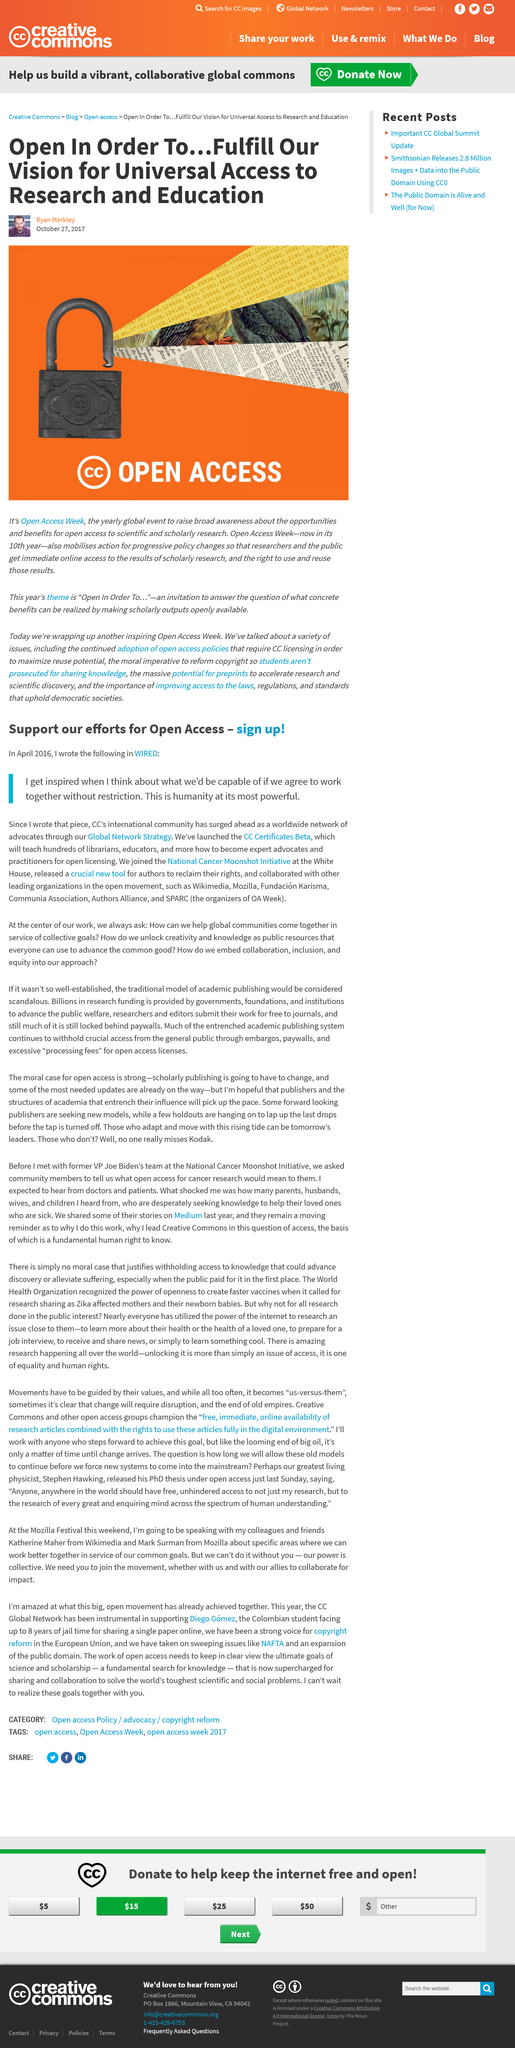List a handful of essential elements in this visual. The National Cancer Moonshot Initiative was jointly launched at the White House. CC Certificates Beta has been launched. Open Access Week aims to increase awareness of open access to scientific and scholarly research. I am inspired by the idea of humanity's potential when we work together without restrictions, as stated in WIRED in April 2016, Our vision at CC is to ensure universal access to research and education for the public through the use of cutting-edge technology and innovative approaches. 